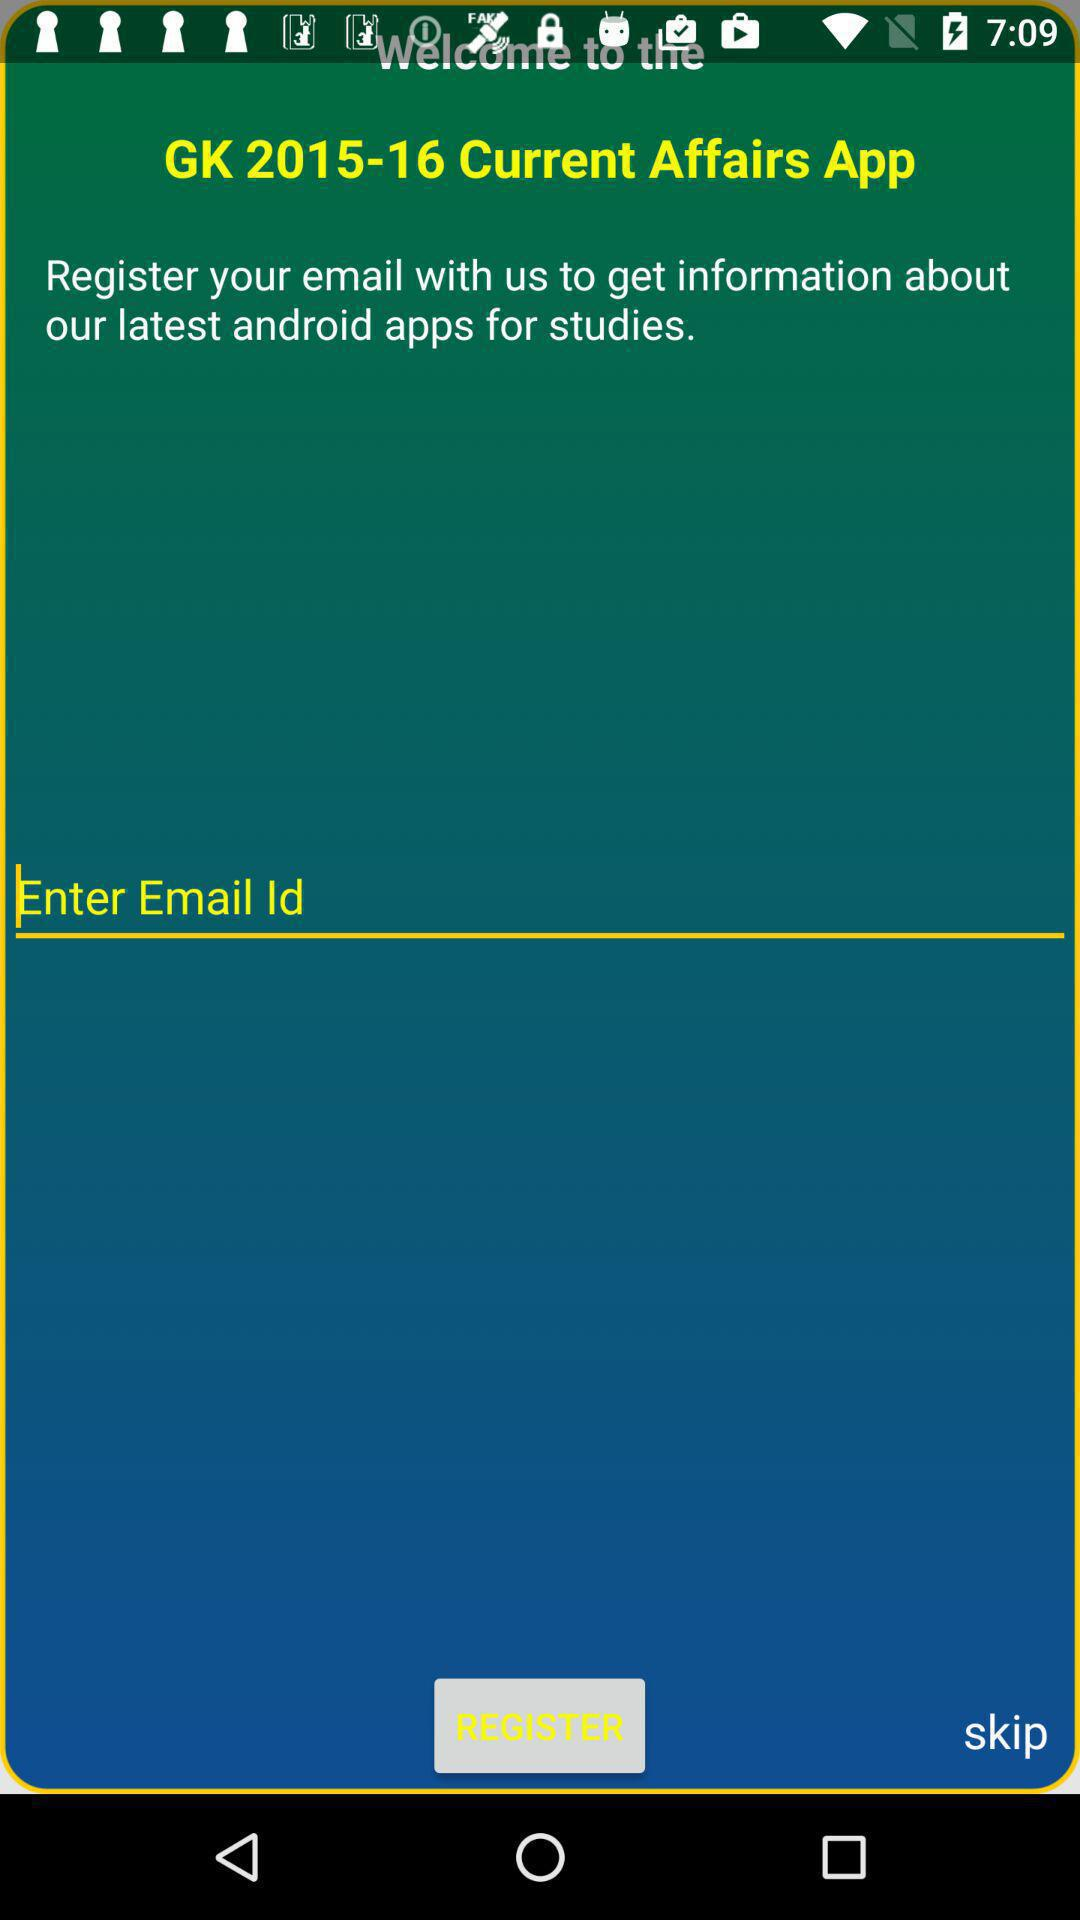What is the requirement for registration? The requirement for registration is your email. 